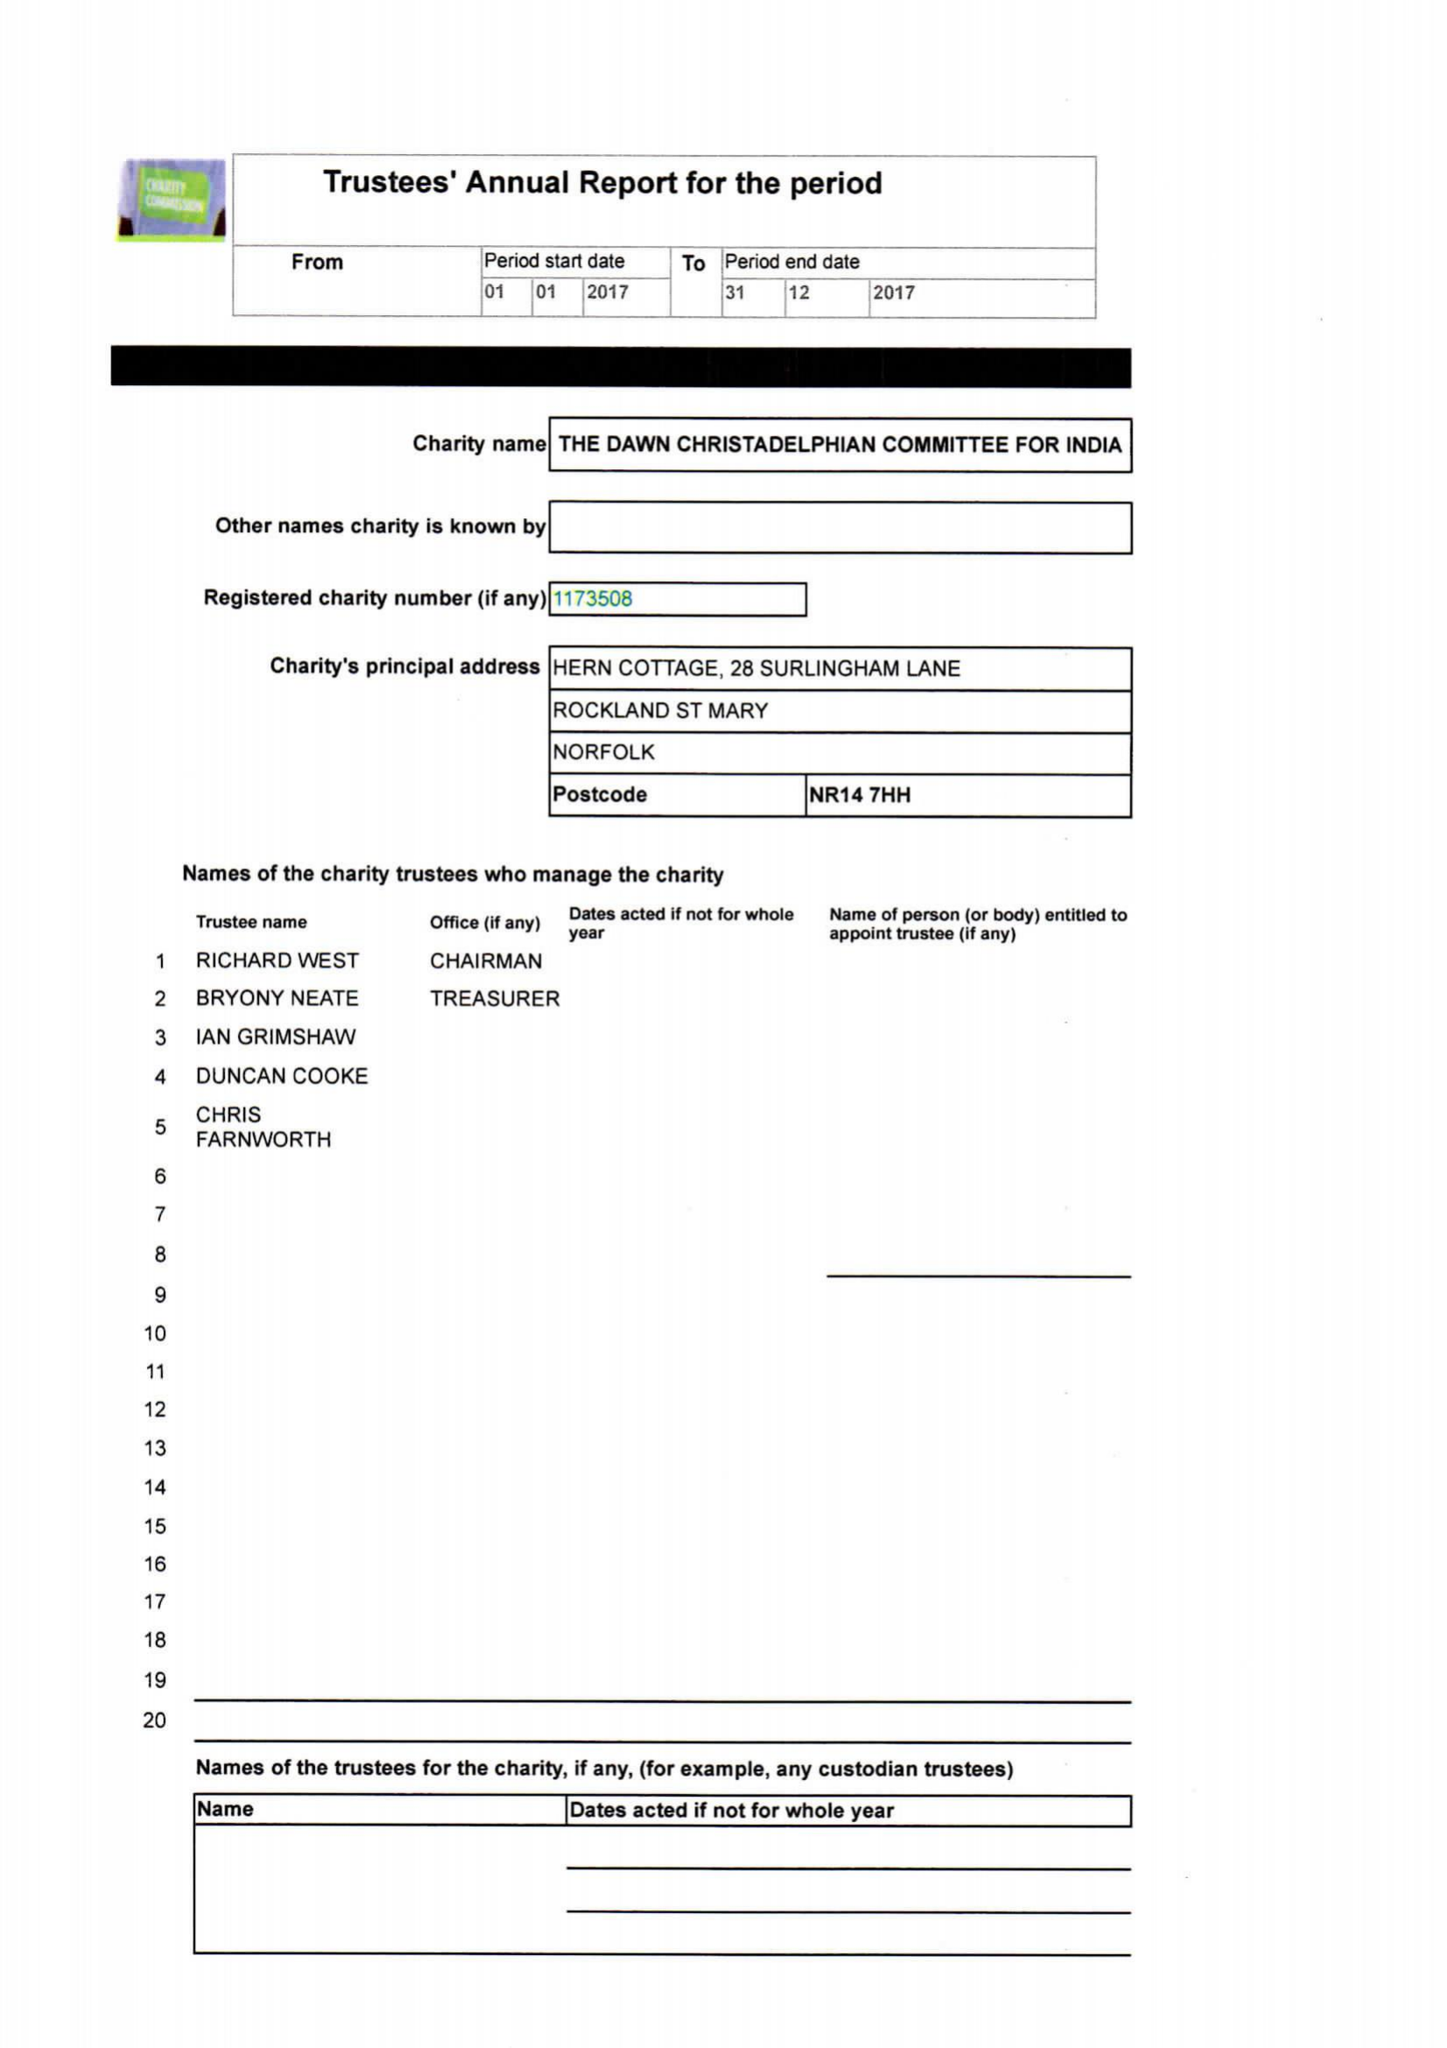What is the value for the income_annually_in_british_pounds?
Answer the question using a single word or phrase. 37823.33 